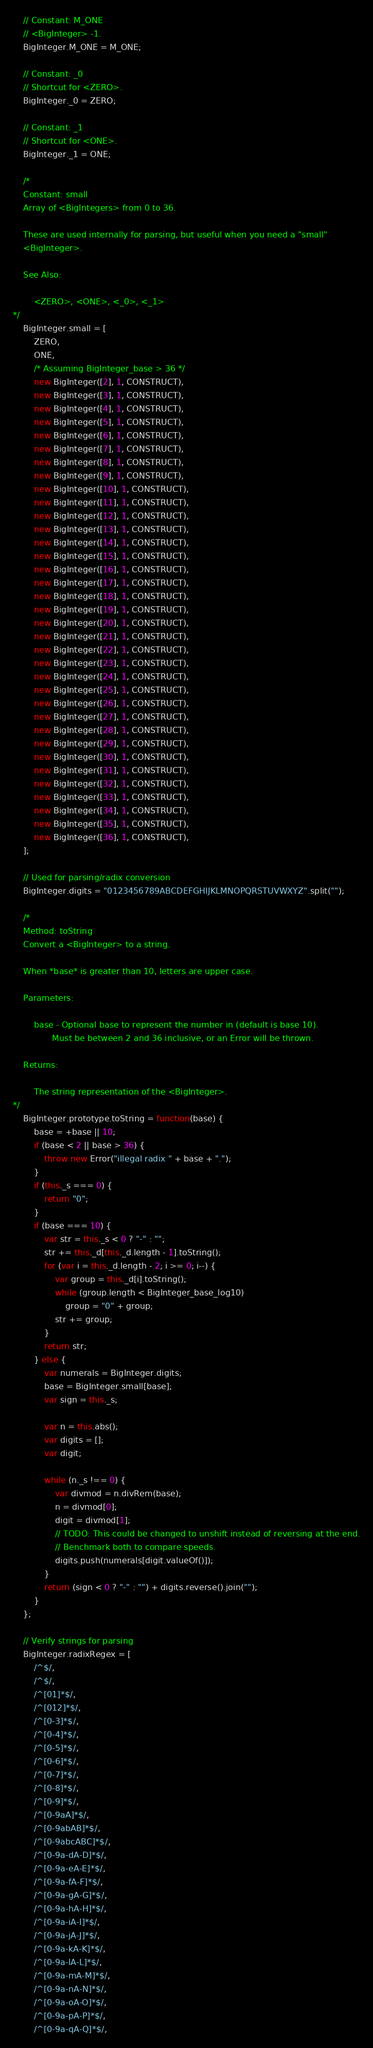Convert code to text. <code><loc_0><loc_0><loc_500><loc_500><_JavaScript_>	// Constant: M_ONE
	// <BigInteger> -1.
	BigInteger.M_ONE = M_ONE;

	// Constant: _0
	// Shortcut for <ZERO>.
	BigInteger._0 = ZERO;

	// Constant: _1
	// Shortcut for <ONE>.
	BigInteger._1 = ONE;

	/*
	Constant: small
	Array of <BigIntegers> from 0 to 36.

	These are used internally for parsing, but useful when you need a "small"
	<BigInteger>.

	See Also:

		<ZERO>, <ONE>, <_0>, <_1>
*/
	BigInteger.small = [
		ZERO,
		ONE,
		/* Assuming BigInteger_base > 36 */
		new BigInteger([2], 1, CONSTRUCT),
		new BigInteger([3], 1, CONSTRUCT),
		new BigInteger([4], 1, CONSTRUCT),
		new BigInteger([5], 1, CONSTRUCT),
		new BigInteger([6], 1, CONSTRUCT),
		new BigInteger([7], 1, CONSTRUCT),
		new BigInteger([8], 1, CONSTRUCT),
		new BigInteger([9], 1, CONSTRUCT),
		new BigInteger([10], 1, CONSTRUCT),
		new BigInteger([11], 1, CONSTRUCT),
		new BigInteger([12], 1, CONSTRUCT),
		new BigInteger([13], 1, CONSTRUCT),
		new BigInteger([14], 1, CONSTRUCT),
		new BigInteger([15], 1, CONSTRUCT),
		new BigInteger([16], 1, CONSTRUCT),
		new BigInteger([17], 1, CONSTRUCT),
		new BigInteger([18], 1, CONSTRUCT),
		new BigInteger([19], 1, CONSTRUCT),
		new BigInteger([20], 1, CONSTRUCT),
		new BigInteger([21], 1, CONSTRUCT),
		new BigInteger([22], 1, CONSTRUCT),
		new BigInteger([23], 1, CONSTRUCT),
		new BigInteger([24], 1, CONSTRUCT),
		new BigInteger([25], 1, CONSTRUCT),
		new BigInteger([26], 1, CONSTRUCT),
		new BigInteger([27], 1, CONSTRUCT),
		new BigInteger([28], 1, CONSTRUCT),
		new BigInteger([29], 1, CONSTRUCT),
		new BigInteger([30], 1, CONSTRUCT),
		new BigInteger([31], 1, CONSTRUCT),
		new BigInteger([32], 1, CONSTRUCT),
		new BigInteger([33], 1, CONSTRUCT),
		new BigInteger([34], 1, CONSTRUCT),
		new BigInteger([35], 1, CONSTRUCT),
		new BigInteger([36], 1, CONSTRUCT),
	];

	// Used for parsing/radix conversion
	BigInteger.digits = "0123456789ABCDEFGHIJKLMNOPQRSTUVWXYZ".split("");

	/*
	Method: toString
	Convert a <BigInteger> to a string.

	When *base* is greater than 10, letters are upper case.

	Parameters:

		base - Optional base to represent the number in (default is base 10).
			   Must be between 2 and 36 inclusive, or an Error will be thrown.

	Returns:

		The string representation of the <BigInteger>.
*/
	BigInteger.prototype.toString = function(base) {
		base = +base || 10;
		if (base < 2 || base > 36) {
			throw new Error("illegal radix " + base + ".");
		}
		if (this._s === 0) {
			return "0";
		}
		if (base === 10) {
			var str = this._s < 0 ? "-" : "";
			str += this._d[this._d.length - 1].toString();
			for (var i = this._d.length - 2; i >= 0; i--) {
				var group = this._d[i].toString();
				while (group.length < BigInteger_base_log10)
					group = "0" + group;
				str += group;
			}
			return str;
		} else {
			var numerals = BigInteger.digits;
			base = BigInteger.small[base];
			var sign = this._s;

			var n = this.abs();
			var digits = [];
			var digit;

			while (n._s !== 0) {
				var divmod = n.divRem(base);
				n = divmod[0];
				digit = divmod[1];
				// TODO: This could be changed to unshift instead of reversing at the end.
				// Benchmark both to compare speeds.
				digits.push(numerals[digit.valueOf()]);
			}
			return (sign < 0 ? "-" : "") + digits.reverse().join("");
		}
	};

	// Verify strings for parsing
	BigInteger.radixRegex = [
		/^$/,
		/^$/,
		/^[01]*$/,
		/^[012]*$/,
		/^[0-3]*$/,
		/^[0-4]*$/,
		/^[0-5]*$/,
		/^[0-6]*$/,
		/^[0-7]*$/,
		/^[0-8]*$/,
		/^[0-9]*$/,
		/^[0-9aA]*$/,
		/^[0-9abAB]*$/,
		/^[0-9abcABC]*$/,
		/^[0-9a-dA-D]*$/,
		/^[0-9a-eA-E]*$/,
		/^[0-9a-fA-F]*$/,
		/^[0-9a-gA-G]*$/,
		/^[0-9a-hA-H]*$/,
		/^[0-9a-iA-I]*$/,
		/^[0-9a-jA-J]*$/,
		/^[0-9a-kA-K]*$/,
		/^[0-9a-lA-L]*$/,
		/^[0-9a-mA-M]*$/,
		/^[0-9a-nA-N]*$/,
		/^[0-9a-oA-O]*$/,
		/^[0-9a-pA-P]*$/,
		/^[0-9a-qA-Q]*$/,</code> 